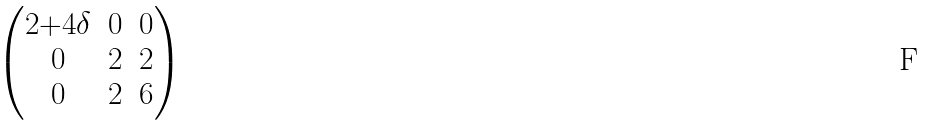<formula> <loc_0><loc_0><loc_500><loc_500>\begin{pmatrix} 2 { + } 4 \delta & 0 & 0 \\ 0 & 2 & 2 \\ 0 & 2 & 6 \end{pmatrix}</formula> 